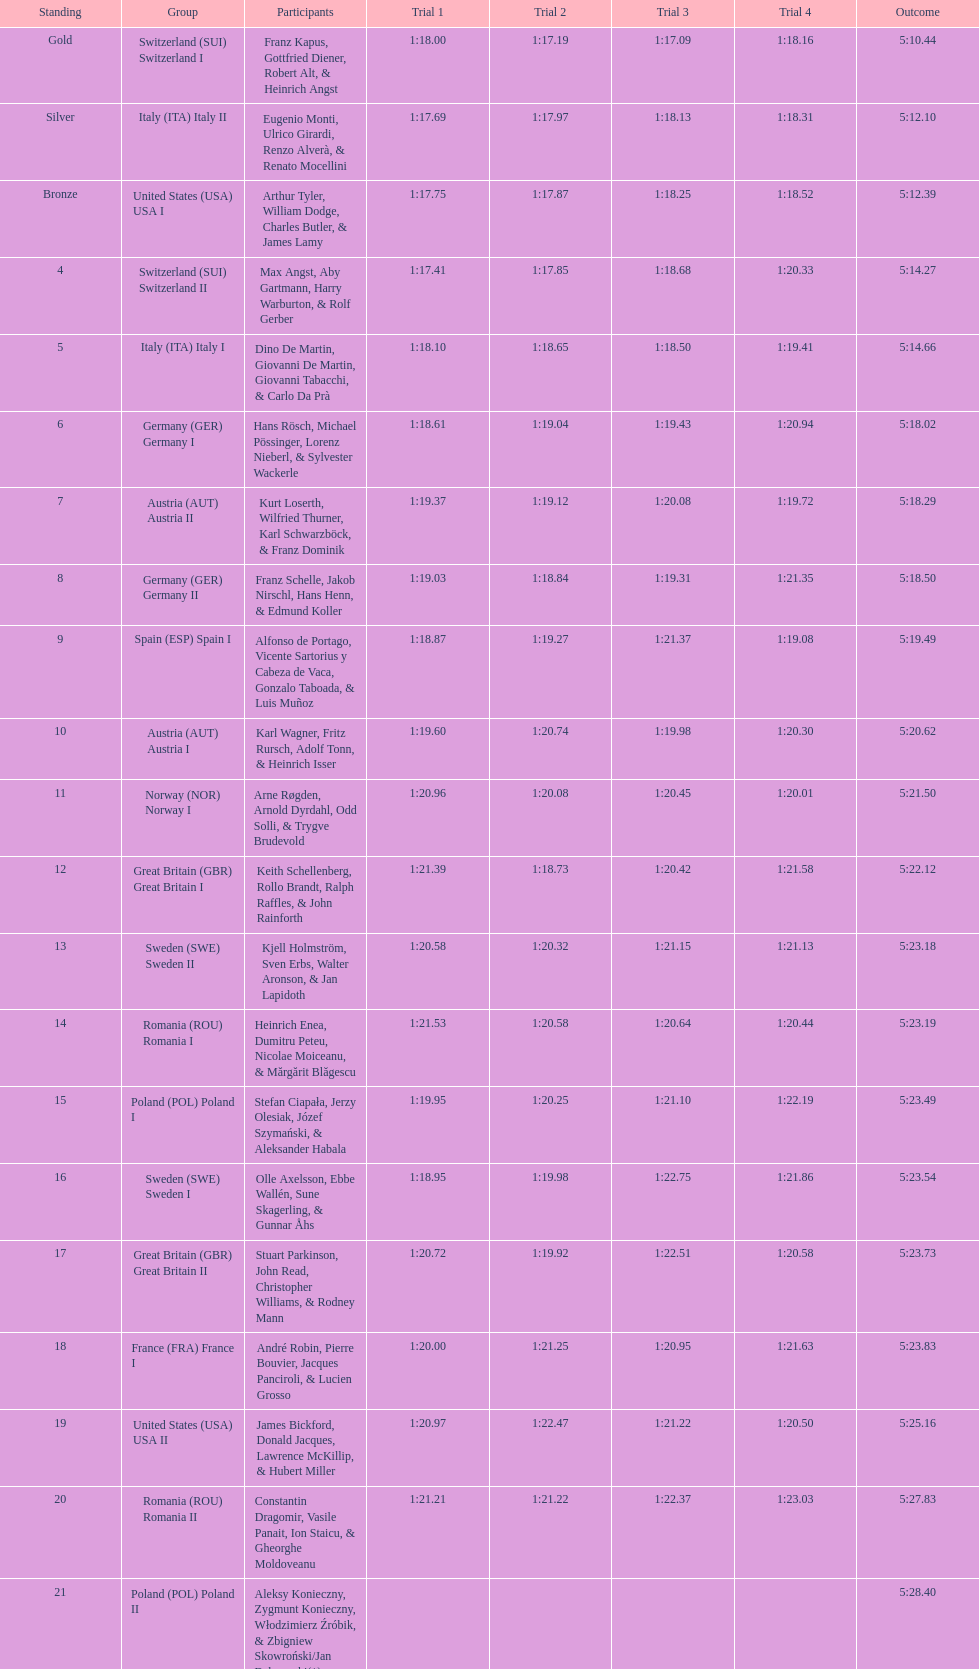What team comes after italy (ita) italy i? Germany I. 